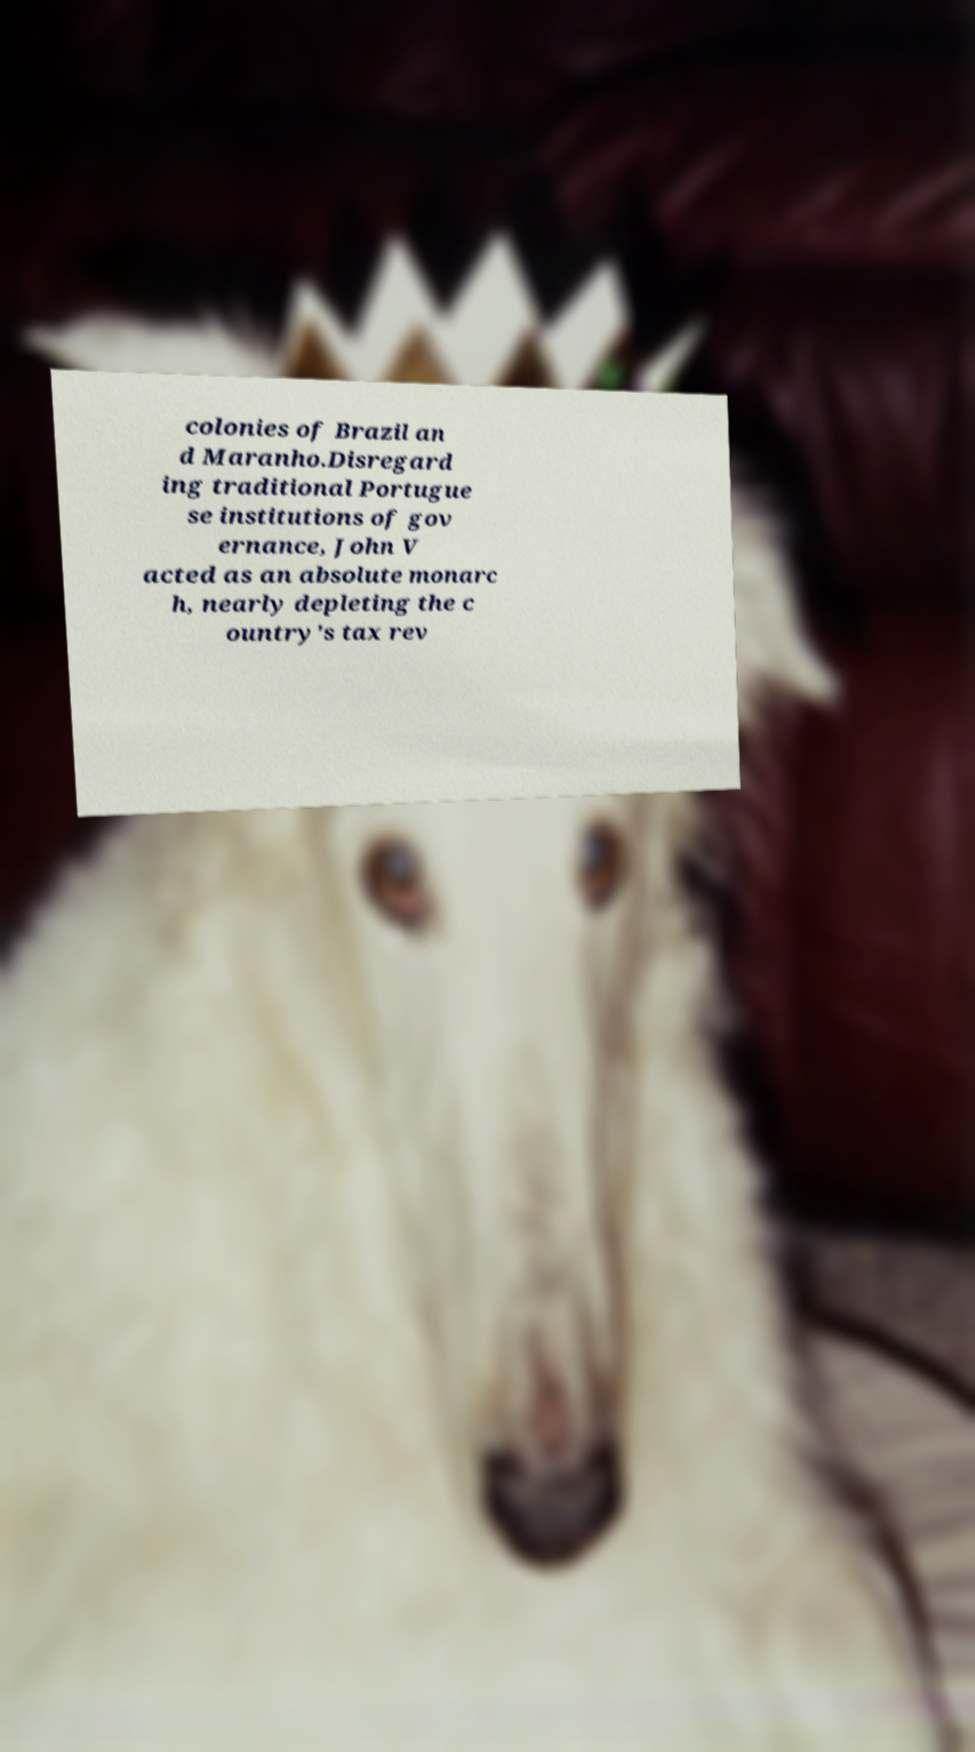I need the written content from this picture converted into text. Can you do that? colonies of Brazil an d Maranho.Disregard ing traditional Portugue se institutions of gov ernance, John V acted as an absolute monarc h, nearly depleting the c ountry's tax rev 